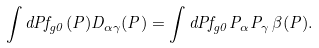Convert formula to latex. <formula><loc_0><loc_0><loc_500><loc_500>\int d { P } f _ { g 0 } ( { P } ) D _ { \alpha \gamma } ( { P } ) = \int d { P } f _ { g 0 } { P _ { \alpha } } { P _ { \gamma } } \, \beta ( { P } ) .</formula> 